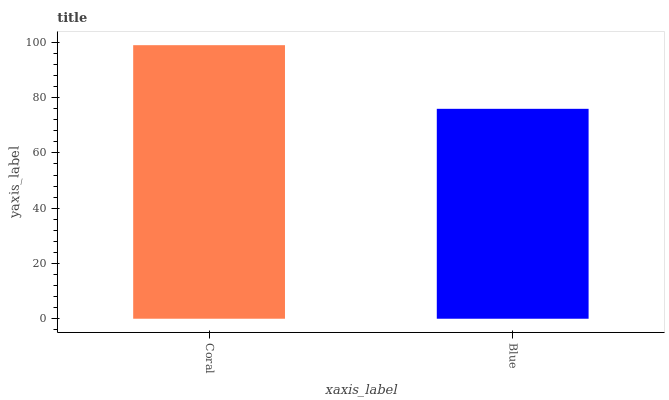Is Blue the minimum?
Answer yes or no. Yes. Is Coral the maximum?
Answer yes or no. Yes. Is Blue the maximum?
Answer yes or no. No. Is Coral greater than Blue?
Answer yes or no. Yes. Is Blue less than Coral?
Answer yes or no. Yes. Is Blue greater than Coral?
Answer yes or no. No. Is Coral less than Blue?
Answer yes or no. No. Is Coral the high median?
Answer yes or no. Yes. Is Blue the low median?
Answer yes or no. Yes. Is Blue the high median?
Answer yes or no. No. Is Coral the low median?
Answer yes or no. No. 